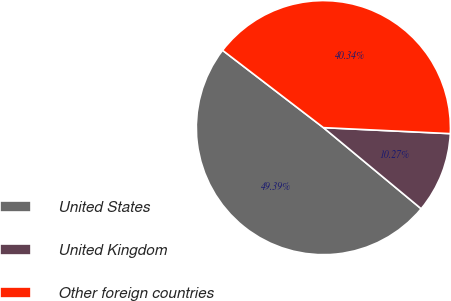<chart> <loc_0><loc_0><loc_500><loc_500><pie_chart><fcel>United States<fcel>United Kingdom<fcel>Other foreign countries<nl><fcel>49.39%<fcel>10.27%<fcel>40.34%<nl></chart> 